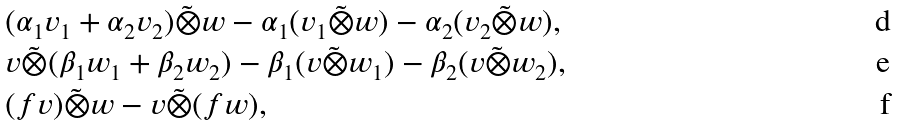Convert formula to latex. <formula><loc_0><loc_0><loc_500><loc_500>& ( \alpha _ { 1 } v _ { 1 } + \alpha _ { 2 } v _ { 2 } ) \tilde { \otimes } w - \alpha _ { 1 } ( v _ { 1 } \tilde { \otimes } w ) - \alpha _ { 2 } ( v _ { 2 } \tilde { \otimes } w ) , \\ & v \tilde { \otimes } ( \beta _ { 1 } w _ { 1 } + \beta _ { 2 } w _ { 2 } ) - \beta _ { 1 } ( v \tilde { \otimes } w _ { 1 } ) - \beta _ { 2 } ( v \tilde { \otimes } w _ { 2 } ) , \\ & ( f v ) \tilde { \otimes } w - v \tilde { \otimes } ( f w ) ,</formula> 